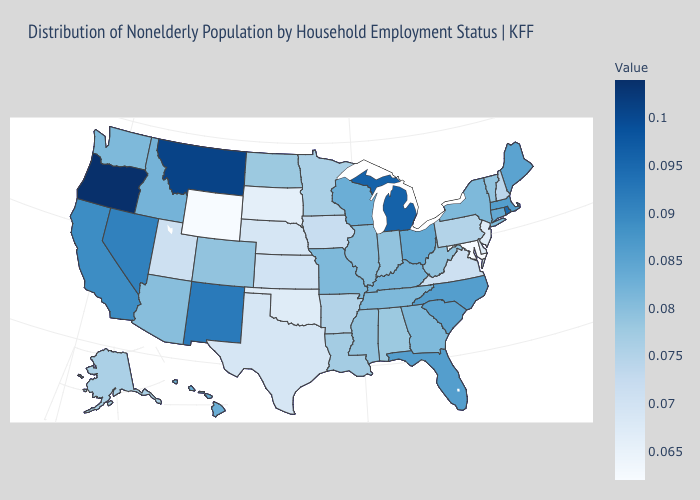Which states have the lowest value in the South?
Keep it brief. Maryland. Among the states that border Colorado , does Nebraska have the highest value?
Write a very short answer. No. Does Oklahoma have the highest value in the USA?
Keep it brief. No. Does Oregon have the highest value in the USA?
Quick response, please. Yes. Which states have the lowest value in the USA?
Keep it brief. Maryland, Wyoming. Which states hav the highest value in the MidWest?
Keep it brief. Michigan. Does Washington have a lower value than Maryland?
Be succinct. No. 